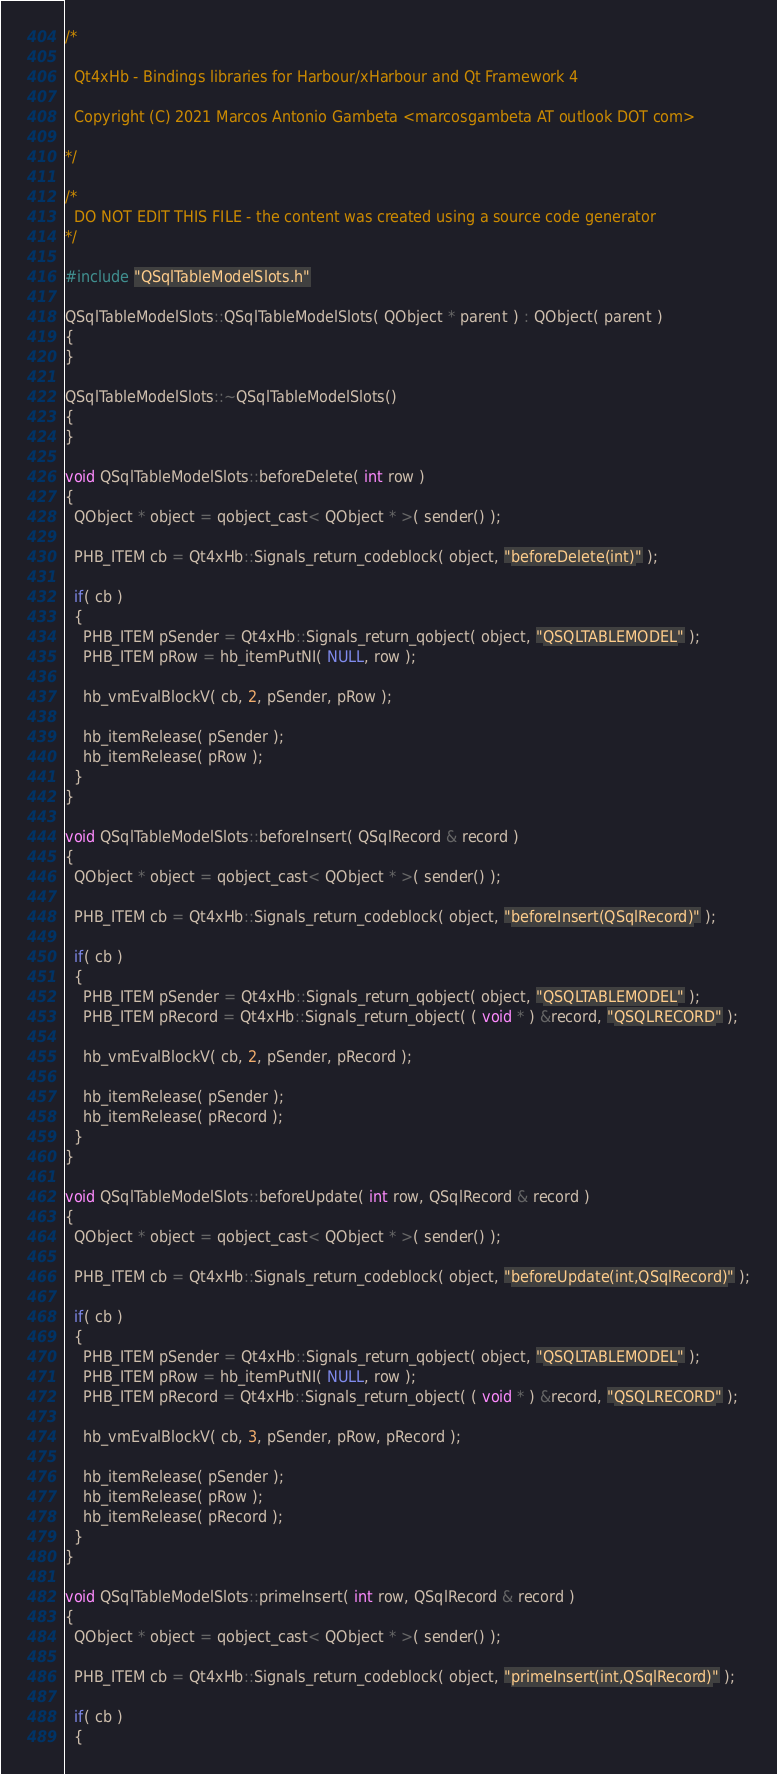<code> <loc_0><loc_0><loc_500><loc_500><_C++_>/*

  Qt4xHb - Bindings libraries for Harbour/xHarbour and Qt Framework 4

  Copyright (C) 2021 Marcos Antonio Gambeta <marcosgambeta AT outlook DOT com>

*/

/*
  DO NOT EDIT THIS FILE - the content was created using a source code generator
*/

#include "QSqlTableModelSlots.h"

QSqlTableModelSlots::QSqlTableModelSlots( QObject * parent ) : QObject( parent )
{
}

QSqlTableModelSlots::~QSqlTableModelSlots()
{
}

void QSqlTableModelSlots::beforeDelete( int row )
{
  QObject * object = qobject_cast< QObject * >( sender() );

  PHB_ITEM cb = Qt4xHb::Signals_return_codeblock( object, "beforeDelete(int)" );

  if( cb )
  {
    PHB_ITEM pSender = Qt4xHb::Signals_return_qobject( object, "QSQLTABLEMODEL" );
    PHB_ITEM pRow = hb_itemPutNI( NULL, row );

    hb_vmEvalBlockV( cb, 2, pSender, pRow );

    hb_itemRelease( pSender );
    hb_itemRelease( pRow );
  }
}

void QSqlTableModelSlots::beforeInsert( QSqlRecord & record )
{
  QObject * object = qobject_cast< QObject * >( sender() );

  PHB_ITEM cb = Qt4xHb::Signals_return_codeblock( object, "beforeInsert(QSqlRecord)" );

  if( cb )
  {
    PHB_ITEM pSender = Qt4xHb::Signals_return_qobject( object, "QSQLTABLEMODEL" );
    PHB_ITEM pRecord = Qt4xHb::Signals_return_object( ( void * ) &record, "QSQLRECORD" );

    hb_vmEvalBlockV( cb, 2, pSender, pRecord );

    hb_itemRelease( pSender );
    hb_itemRelease( pRecord );
  }
}

void QSqlTableModelSlots::beforeUpdate( int row, QSqlRecord & record )
{
  QObject * object = qobject_cast< QObject * >( sender() );

  PHB_ITEM cb = Qt4xHb::Signals_return_codeblock( object, "beforeUpdate(int,QSqlRecord)" );

  if( cb )
  {
    PHB_ITEM pSender = Qt4xHb::Signals_return_qobject( object, "QSQLTABLEMODEL" );
    PHB_ITEM pRow = hb_itemPutNI( NULL, row );
    PHB_ITEM pRecord = Qt4xHb::Signals_return_object( ( void * ) &record, "QSQLRECORD" );

    hb_vmEvalBlockV( cb, 3, pSender, pRow, pRecord );

    hb_itemRelease( pSender );
    hb_itemRelease( pRow );
    hb_itemRelease( pRecord );
  }
}

void QSqlTableModelSlots::primeInsert( int row, QSqlRecord & record )
{
  QObject * object = qobject_cast< QObject * >( sender() );

  PHB_ITEM cb = Qt4xHb::Signals_return_codeblock( object, "primeInsert(int,QSqlRecord)" );

  if( cb )
  {</code> 